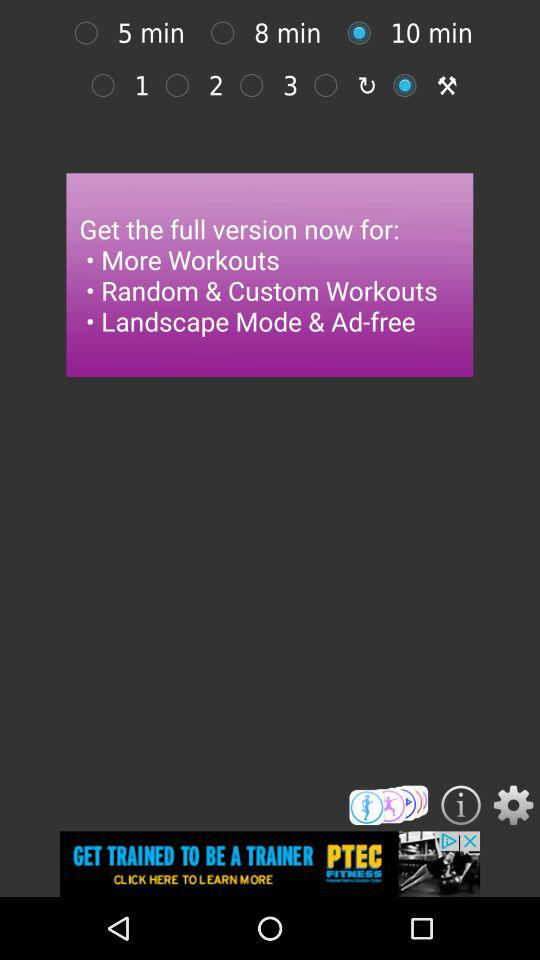How much does the full version cost?
When the provided information is insufficient, respond with <no answer>. <no answer> 